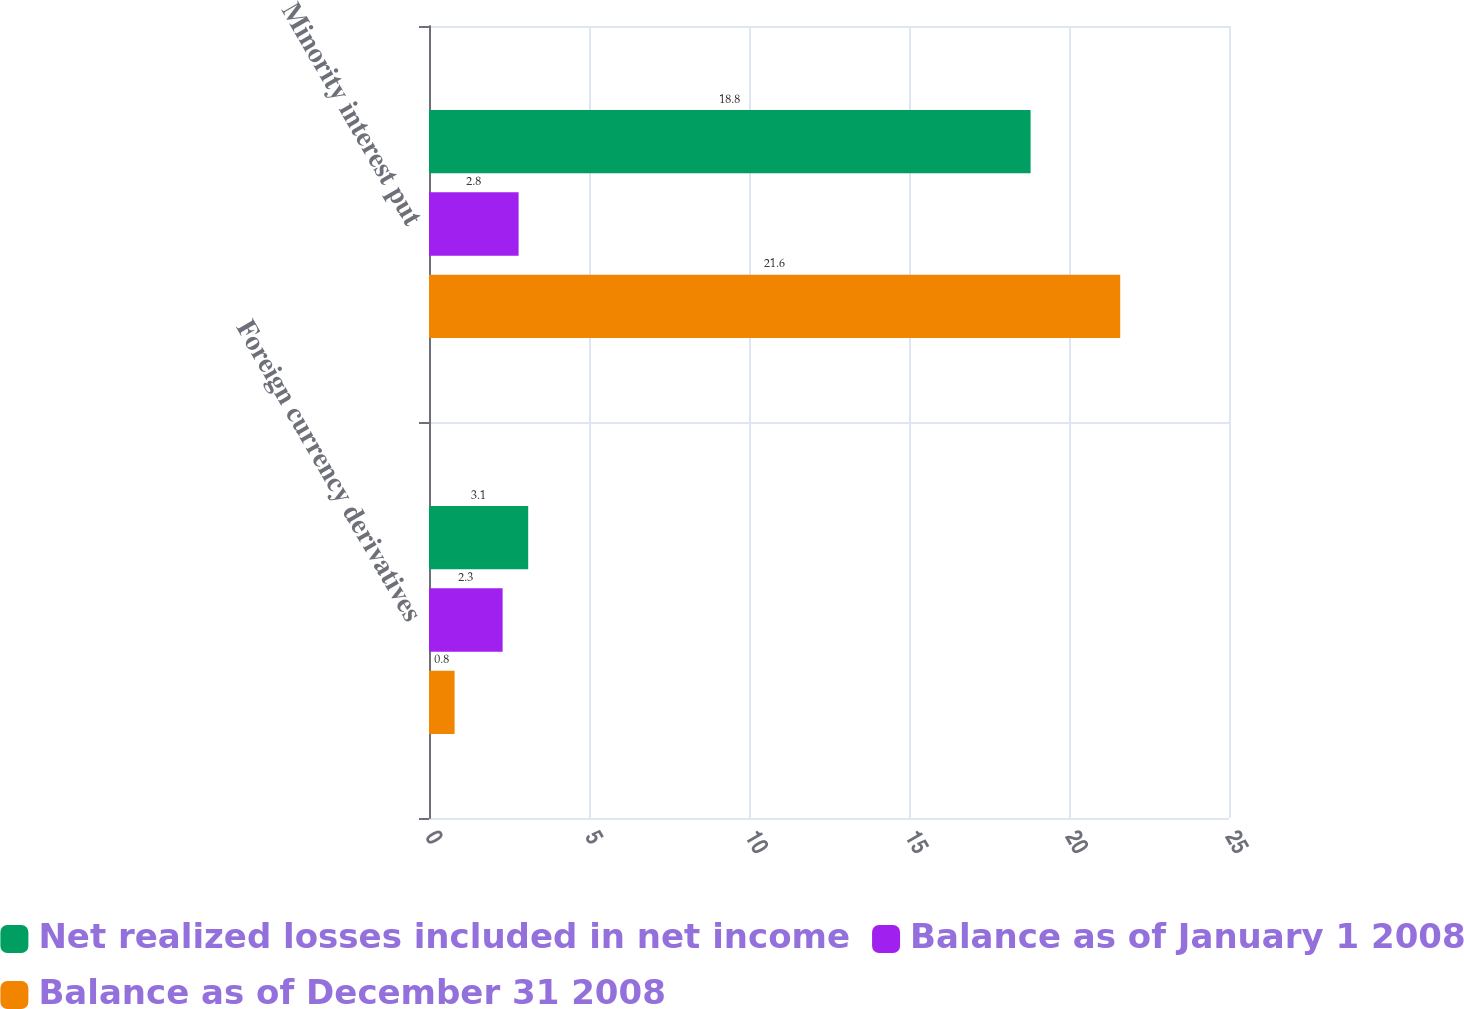Convert chart. <chart><loc_0><loc_0><loc_500><loc_500><stacked_bar_chart><ecel><fcel>Foreign currency derivatives<fcel>Minority interest put<nl><fcel>Net realized losses included in net income<fcel>3.1<fcel>18.8<nl><fcel>Balance as of January 1 2008<fcel>2.3<fcel>2.8<nl><fcel>Balance as of December 31 2008<fcel>0.8<fcel>21.6<nl></chart> 